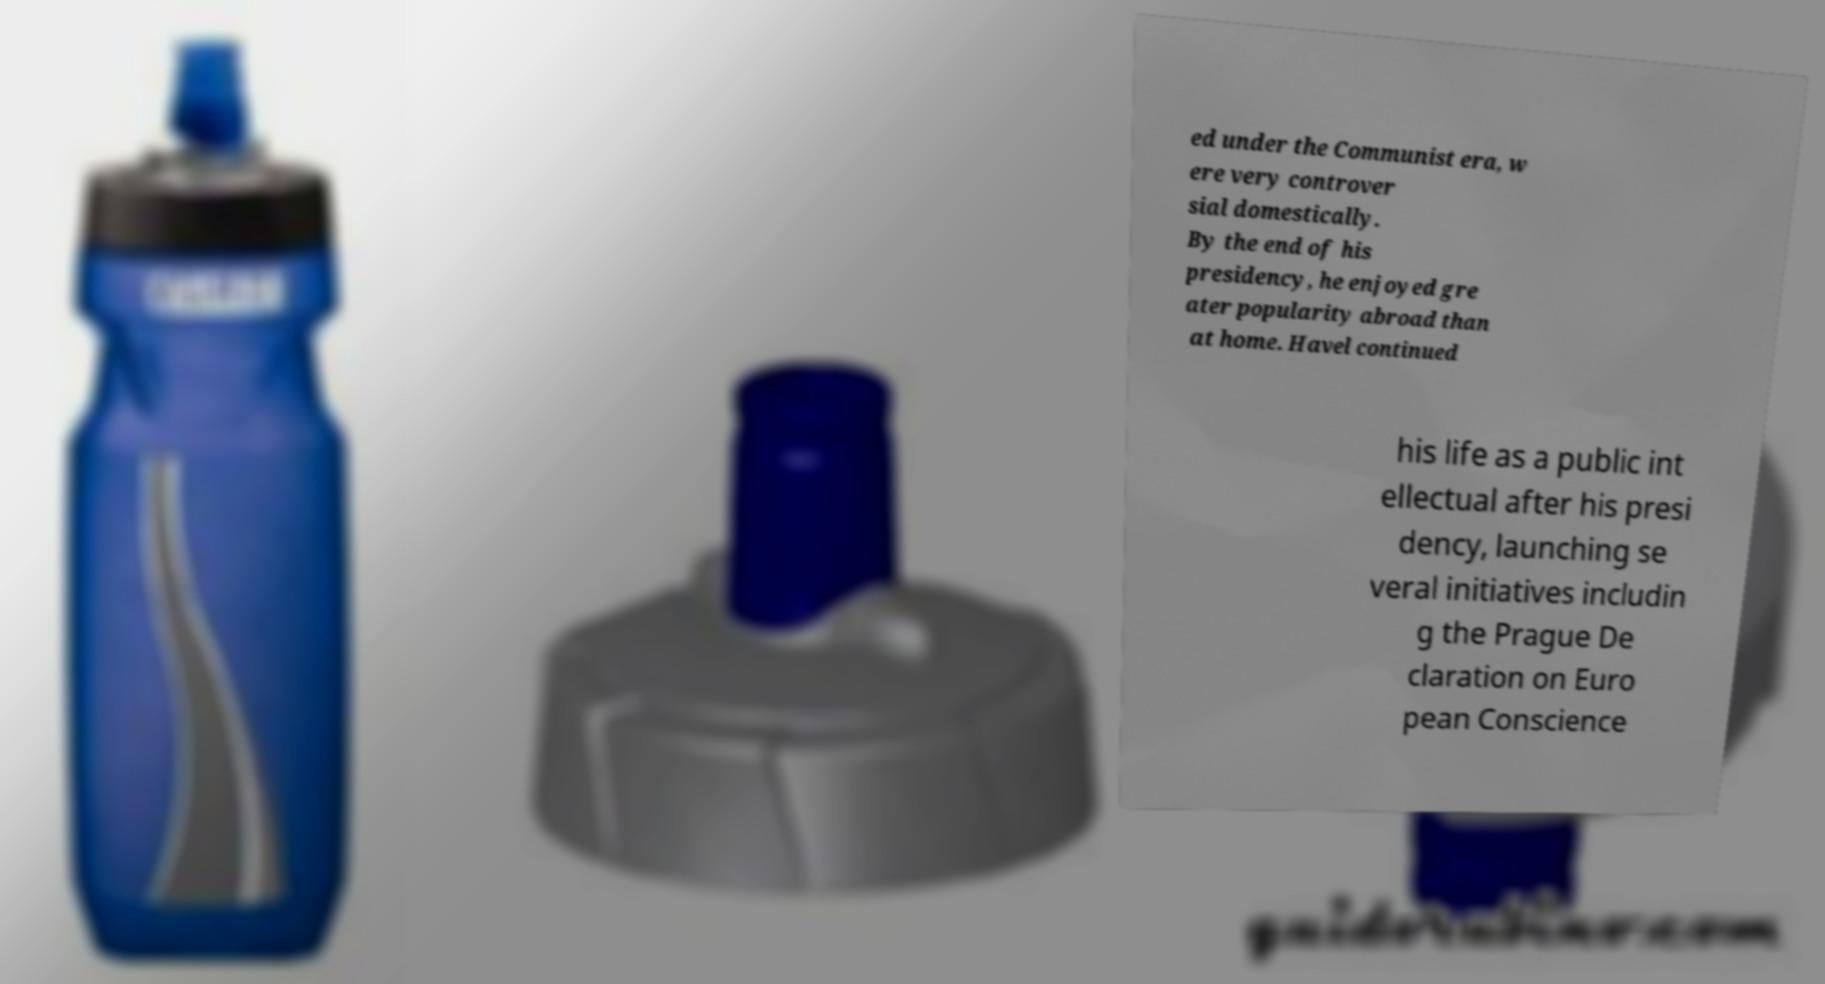There's text embedded in this image that I need extracted. Can you transcribe it verbatim? ed under the Communist era, w ere very controver sial domestically. By the end of his presidency, he enjoyed gre ater popularity abroad than at home. Havel continued his life as a public int ellectual after his presi dency, launching se veral initiatives includin g the Prague De claration on Euro pean Conscience 